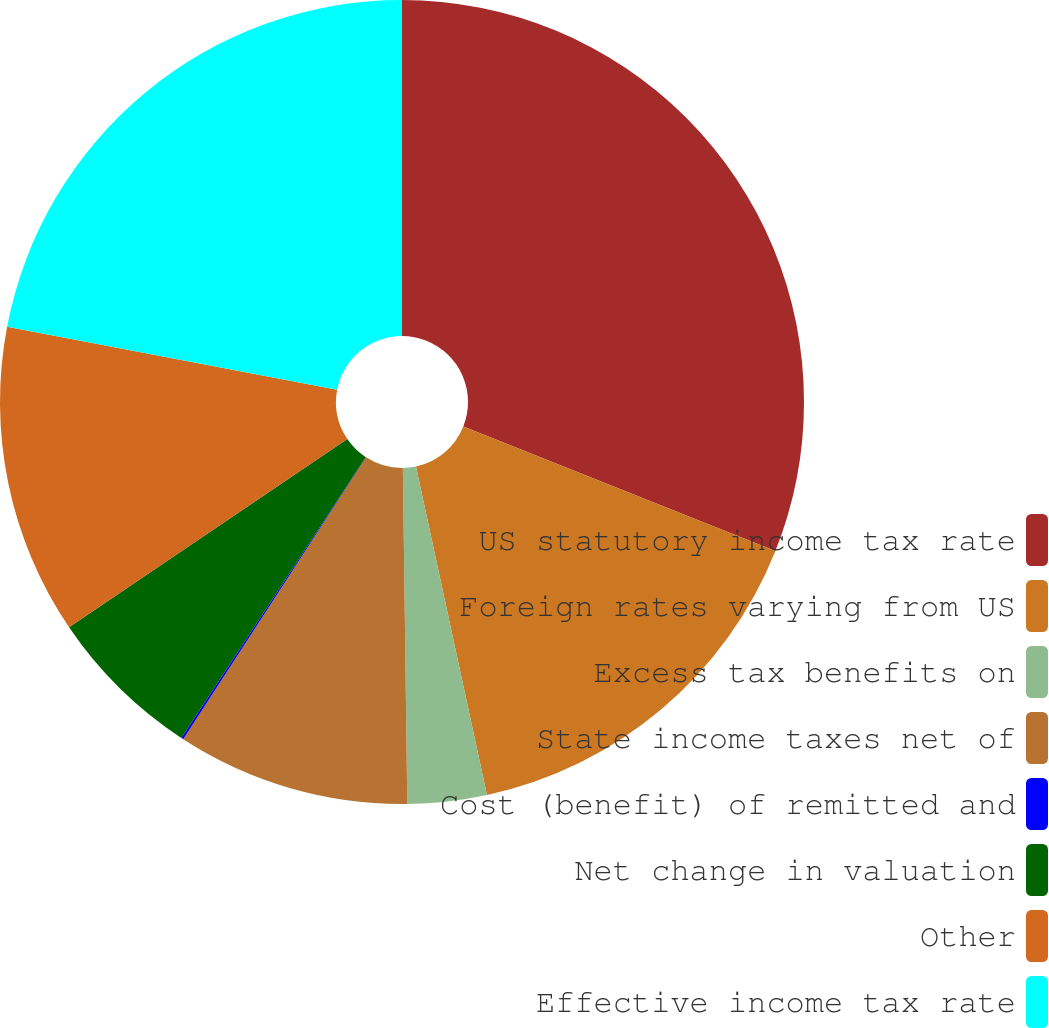Convert chart. <chart><loc_0><loc_0><loc_500><loc_500><pie_chart><fcel>US statutory income tax rate<fcel>Foreign rates varying from US<fcel>Excess tax benefits on<fcel>State income taxes net of<fcel>Cost (benefit) of remitted and<fcel>Net change in valuation<fcel>Other<fcel>Effective income tax rate<nl><fcel>31.04%<fcel>15.57%<fcel>3.18%<fcel>9.37%<fcel>0.09%<fcel>6.28%<fcel>12.47%<fcel>22.0%<nl></chart> 